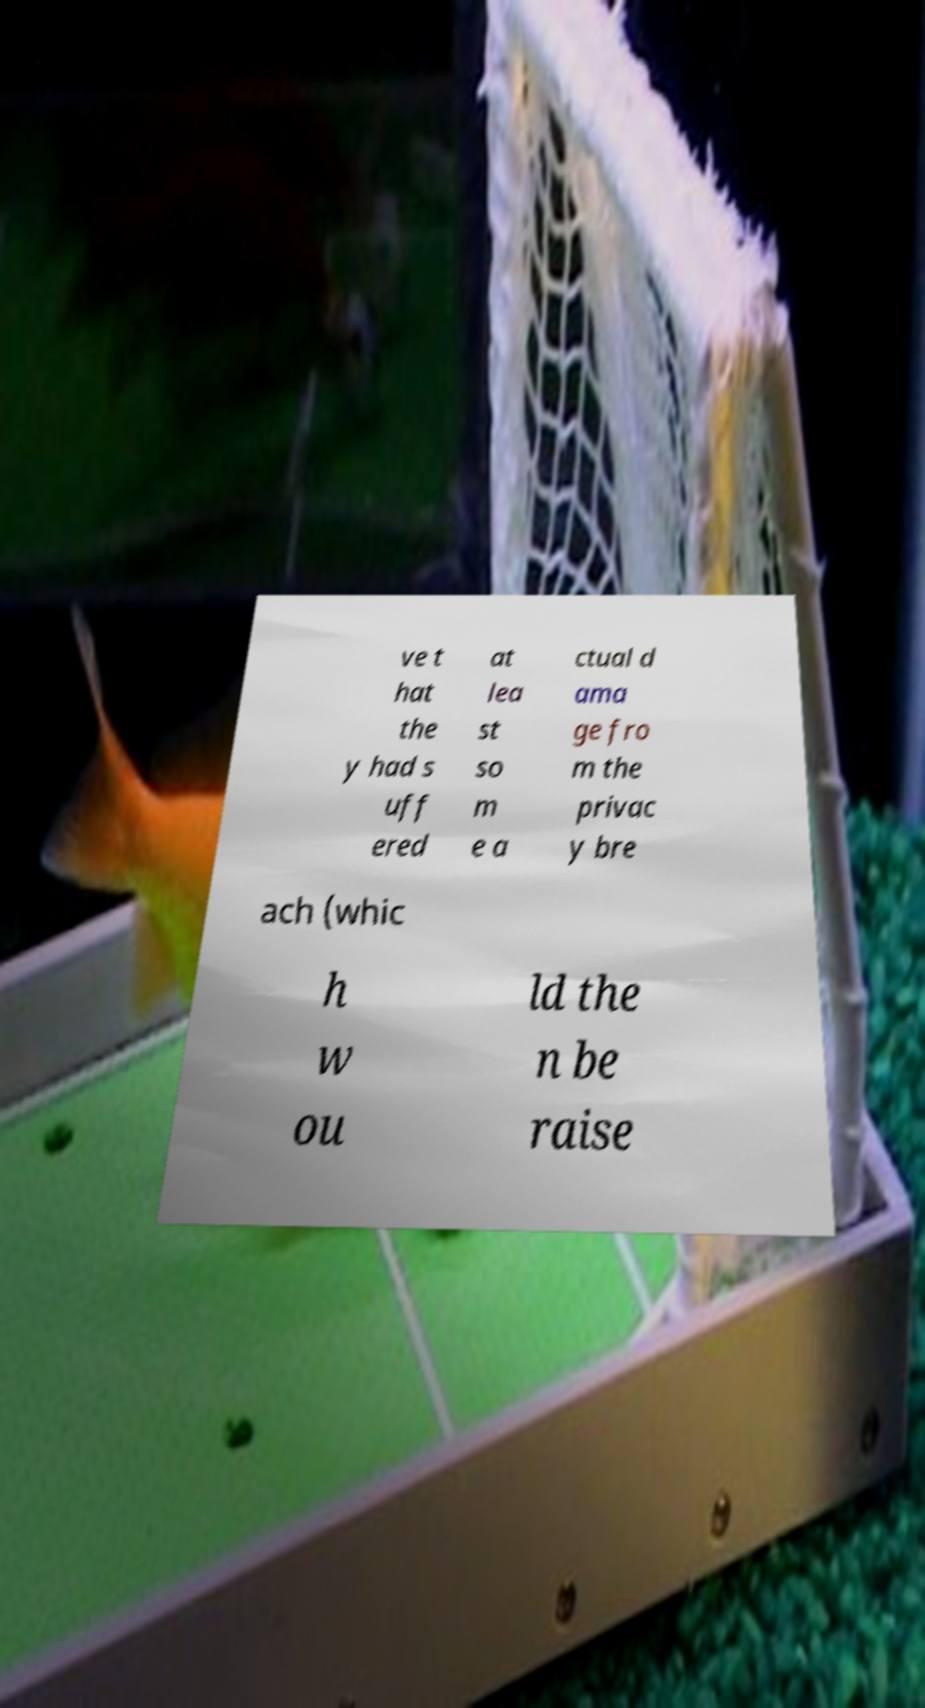Please identify and transcribe the text found in this image. ve t hat the y had s uff ered at lea st so m e a ctual d ama ge fro m the privac y bre ach (whic h w ou ld the n be raise 